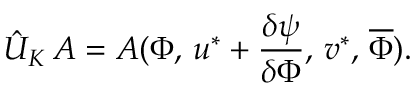Convert formula to latex. <formula><loc_0><loc_0><loc_500><loc_500>\hat { U } _ { K } \, A = A ( \Phi , \, u ^ { * } + \frac { \delta \psi } { \delta \Phi } , \, v ^ { * } , \, \overline { \Phi } ) .</formula> 